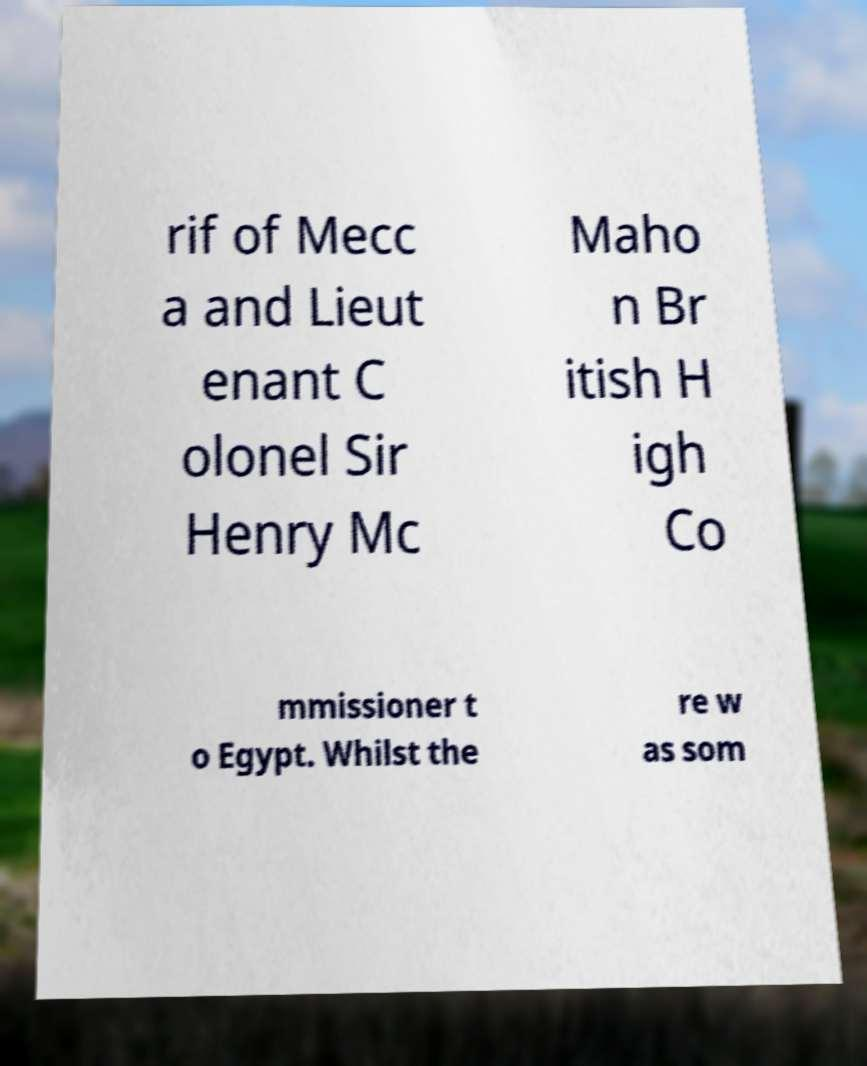For documentation purposes, I need the text within this image transcribed. Could you provide that? rif of Mecc a and Lieut enant C olonel Sir Henry Mc Maho n Br itish H igh Co mmissioner t o Egypt. Whilst the re w as som 